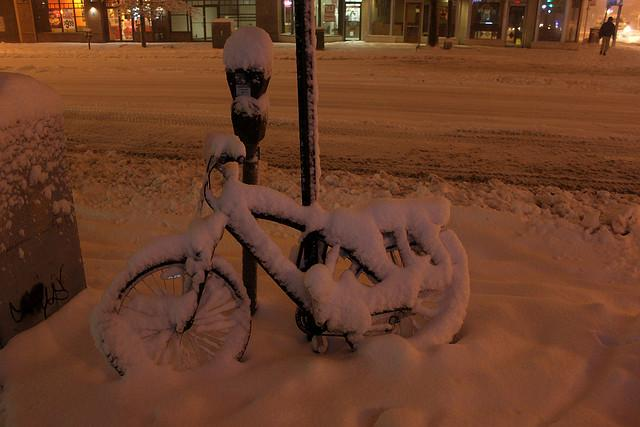How much did the owner of this bike put into the parking meter here?

Choices:
A) $1
B) .25
C) penny
D) none none 